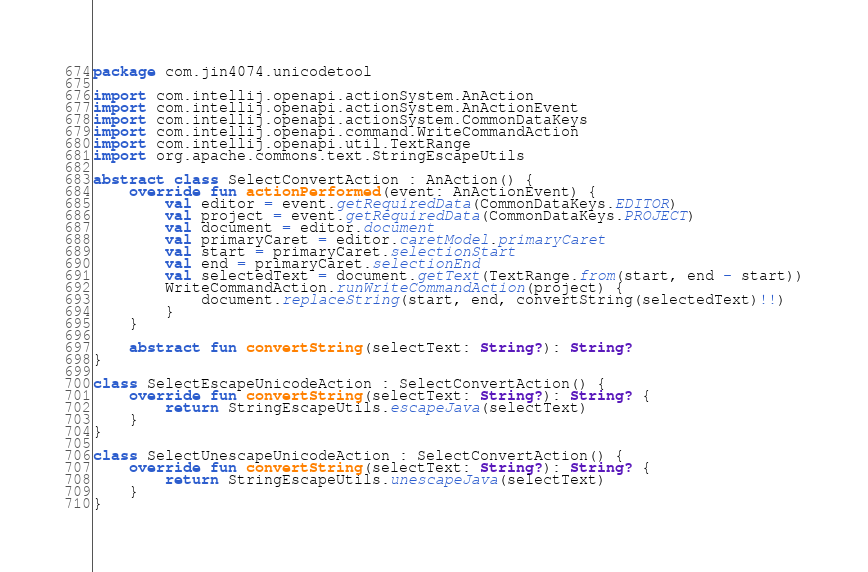Convert code to text. <code><loc_0><loc_0><loc_500><loc_500><_Kotlin_>package com.jin4074.unicodetool

import com.intellij.openapi.actionSystem.AnAction
import com.intellij.openapi.actionSystem.AnActionEvent
import com.intellij.openapi.actionSystem.CommonDataKeys
import com.intellij.openapi.command.WriteCommandAction
import com.intellij.openapi.util.TextRange
import org.apache.commons.text.StringEscapeUtils

abstract class SelectConvertAction : AnAction() {
    override fun actionPerformed(event: AnActionEvent) {
        val editor = event.getRequiredData(CommonDataKeys.EDITOR)
        val project = event.getRequiredData(CommonDataKeys.PROJECT)
        val document = editor.document
        val primaryCaret = editor.caretModel.primaryCaret
        val start = primaryCaret.selectionStart
        val end = primaryCaret.selectionEnd
        val selectedText = document.getText(TextRange.from(start, end - start))
        WriteCommandAction.runWriteCommandAction(project) {
            document.replaceString(start, end, convertString(selectedText)!!)
        }
    }

    abstract fun convertString(selectText: String?): String?
}

class SelectEscapeUnicodeAction : SelectConvertAction() {
    override fun convertString(selectText: String?): String? {
        return StringEscapeUtils.escapeJava(selectText)
    }
}

class SelectUnescapeUnicodeAction : SelectConvertAction() {
    override fun convertString(selectText: String?): String? {
        return StringEscapeUtils.unescapeJava(selectText)
    }
}</code> 